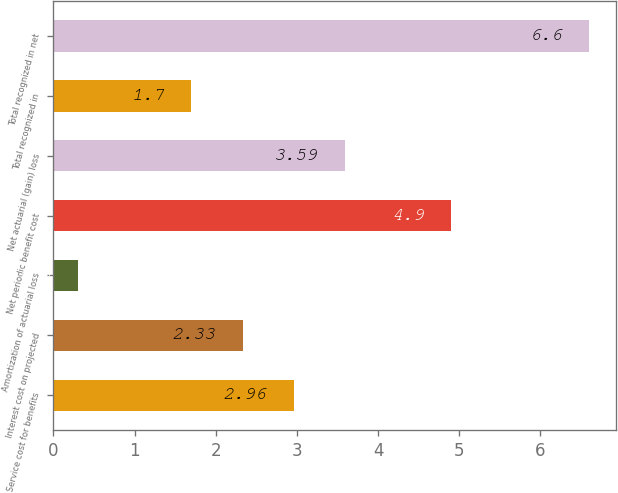Convert chart to OTSL. <chart><loc_0><loc_0><loc_500><loc_500><bar_chart><fcel>Service cost for benefits<fcel>Interest cost on projected<fcel>Amortization of actuarial loss<fcel>Net periodic benefit cost<fcel>Net actuarial (gain) loss<fcel>Total recognized in<fcel>Total recognized in net<nl><fcel>2.96<fcel>2.33<fcel>0.3<fcel>4.9<fcel>3.59<fcel>1.7<fcel>6.6<nl></chart> 